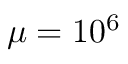<formula> <loc_0><loc_0><loc_500><loc_500>\mu = 1 0 ^ { 6 }</formula> 